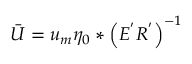<formula> <loc_0><loc_0><loc_500><loc_500>\ B a r { U } = u _ { m } \eta _ { 0 } * \left ( E ^ { ^ { \prime } } R ^ { ^ { \prime } } \right ) ^ { - 1 }</formula> 